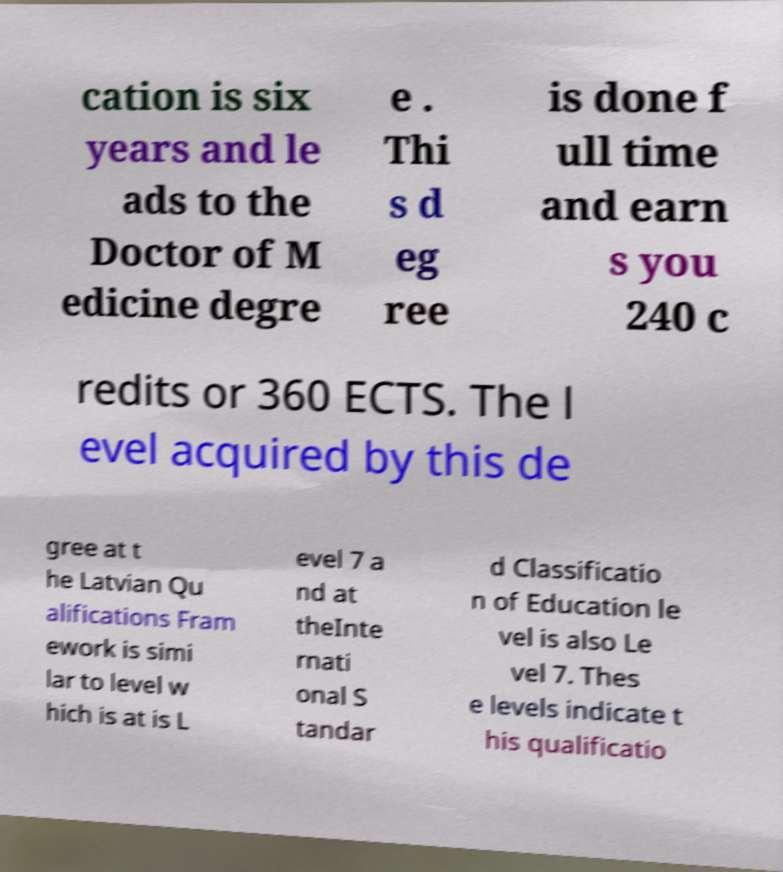Please read and relay the text visible in this image. What does it say? cation is six years and le ads to the Doctor of M edicine degre e . Thi s d eg ree is done f ull time and earn s you 240 c redits or 360 ECTS. The l evel acquired by this de gree at t he Latvian Qu alifications Fram ework is simi lar to level w hich is at is L evel 7 a nd at theInte rnati onal S tandar d Classificatio n of Education le vel is also Le vel 7. Thes e levels indicate t his qualificatio 